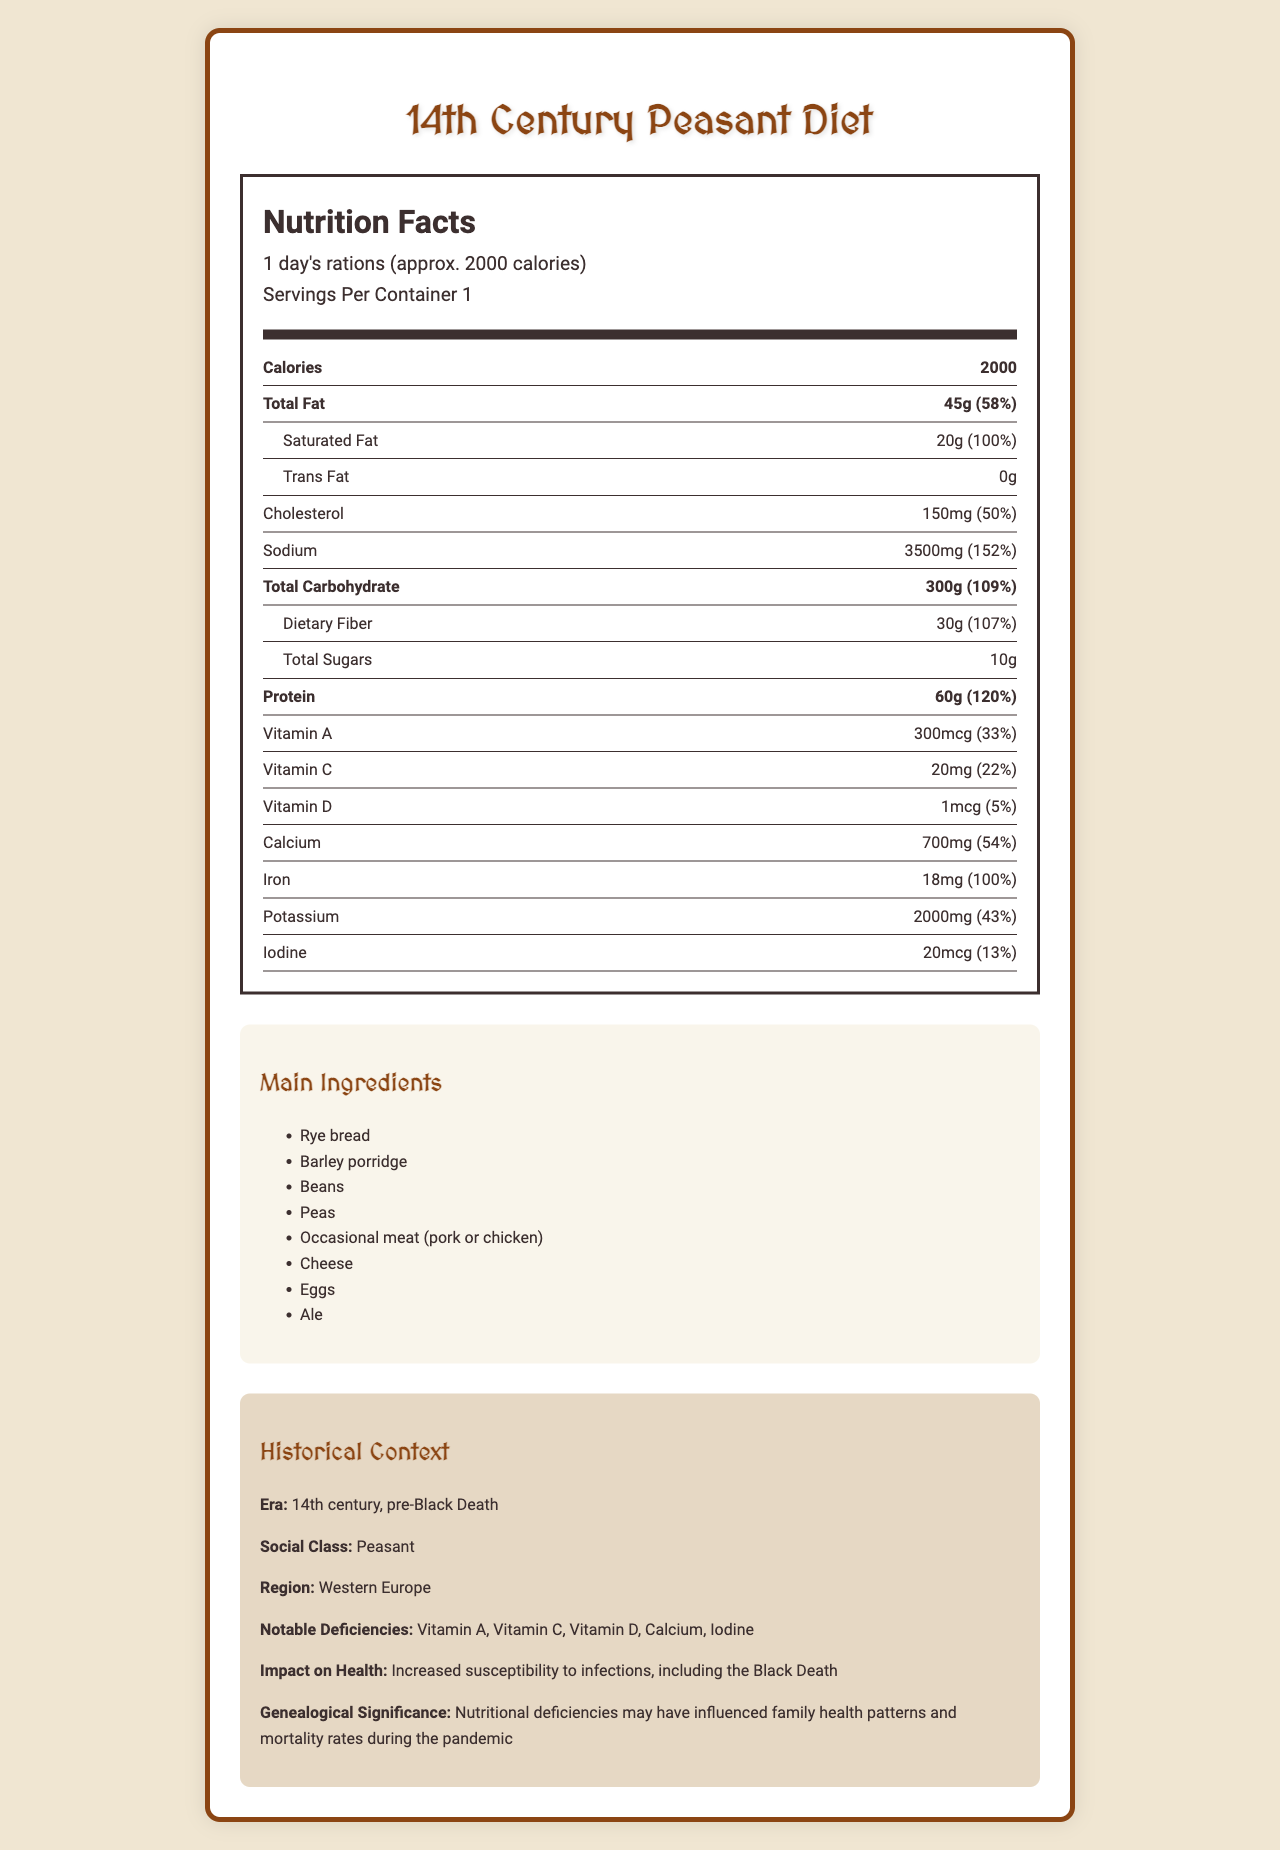what is the serving size? The serving size is mentioned at the beginning of the nutrition information.
Answer: 1 day's rations (approx. 2000 calories) how much total fat is in the diet per serving? The total fat per serving is listed under the nutrition facts.
Answer: 45g what is the daily value percentage of sodium? The daily value percentage for sodium is provided next to its amount in the nutrition facts section.
Answer: 152% how much protein is there per serving? The amount of protein per serving is listed in the nutrition facts.
Answer: 60g which nutrient is severely deficient and can lead to goiter? The severe deficiency of iodine, leading to goiter prevalence, is mentioned in the historical context section.
Answer: Iodine how many grams of saturated fat are included in the diet? A. 0g B. 20g C. 45g D. 150mg The saturated fat amount is listed as 20g in the nutrition facts.
Answer: B. 20g which macronutrient is primarily obtained from bread and grains? A. Protein B. Total Carbohydrate C. Dietary Fiber D. Total Sugar It is stated that the main source of carbohydrates is bread and grains.
Answer: B. Total Carbohydrate is the amount of trans fat in the diet significant? The document states that the trans fat amount is 0g.
Answer: No summarize the main idea of the document. The summary captures the essence of the document by emphasizing key nutritional details and their historical health implications.
Answer: The document provides a detailed nutritional analysis of a typical 14th-century peasant diet, highlighting significant nutrient deficiencies such as Vitamin A, Vitamin C, Vitamin D, Calcium, and Iodine. It also outlines the health impact of these deficiencies on the peasant population, especially amidst the Black Death, where poor nutrition may have influenced health patterns and mortality rates. what were the primary sources of calcium in the diet? The document notes limited dairy consumption as a reason for calcium deficiency, implying dairy was the primary source of calcium.
Answer: Dairy products how much vitamin C is there per serving, and is it considered sufficient? The vitamin C amount is listed as 20mg with a daily value of 22%, indicating deficiency due to limited access to fresh fruits.
Answer: 20mg; No, it is only 22% of the daily value. explain the impact of nutritional deficiencies on the peasant population's health during the Black Death. The historical context section states that these deficiencies increased susceptibility to infections, including the Black Death, affecting health patterns and mortality rates.
Answer: Increased susceptibility to infections and higher mortality rates during the pandemic. how were the peasants' primary sources of protein different from today's typical sources? The primary sources of protein included beans, peas, occasional meat, cheese, and eggs, as listed in the main ingredients, differing from today's more varied sources including more frequent meat and dairy consumption.
Answer: Mainly from beans, peas, occasional meat, cheese, and eggs what percentage of the daily value of iron does the diet provide? The daily value percentage for iron is listed in the nutrition facts.
Answer: 100% what was the primary reason for high sodium content in the diet? The document notes that high sodium content is due to salt preservation methods.
Answer: Salt preservation methods which vitamins are notably deficient in this diet? The historical context lists Vitamin A, C, and D as notable deficiencies.
Answer: Vitamin A, Vitamin C, Vitamin D how can genealogical research benefit from understanding the nutrition facts of a 14th-century peasant diet? The document explains that nutrition deficiencies may have influenced family health patterns and mortality rates during the pandemic.
Answer: It can help understand family health patterns and mortality rates during the Black Death. what is a common deficiency in Vitamin D attributed to? The document lists limited sun exposure and dairy as reasons for Vitamin D deficiency.
Answer: Limited sun exposure and dairy can the exact consumption of rye bread per serving be determined from the document? The document lists rye bread as an ingredient but does not specify the exact amount consumed per serving.
Answer: Not enough information 